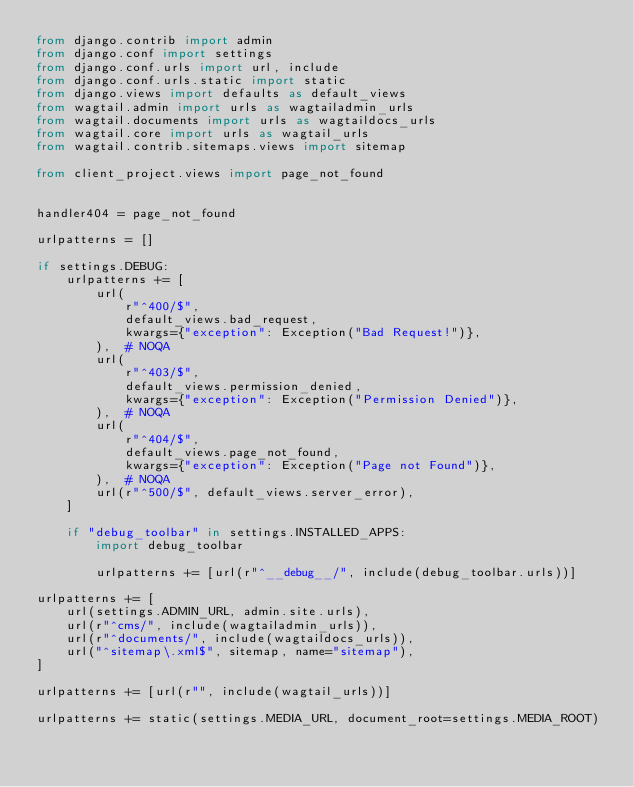<code> <loc_0><loc_0><loc_500><loc_500><_Python_>from django.contrib import admin
from django.conf import settings
from django.conf.urls import url, include
from django.conf.urls.static import static
from django.views import defaults as default_views
from wagtail.admin import urls as wagtailadmin_urls
from wagtail.documents import urls as wagtaildocs_urls
from wagtail.core import urls as wagtail_urls
from wagtail.contrib.sitemaps.views import sitemap

from client_project.views import page_not_found


handler404 = page_not_found

urlpatterns = []

if settings.DEBUG:
    urlpatterns += [
        url(
            r"^400/$",
            default_views.bad_request,
            kwargs={"exception": Exception("Bad Request!")},
        ),  # NOQA
        url(
            r"^403/$",
            default_views.permission_denied,
            kwargs={"exception": Exception("Permission Denied")},
        ),  # NOQA
        url(
            r"^404/$",
            default_views.page_not_found,
            kwargs={"exception": Exception("Page not Found")},
        ),  # NOQA
        url(r"^500/$", default_views.server_error),
    ]

    if "debug_toolbar" in settings.INSTALLED_APPS:
        import debug_toolbar

        urlpatterns += [url(r"^__debug__/", include(debug_toolbar.urls))]

urlpatterns += [
    url(settings.ADMIN_URL, admin.site.urls),
    url(r"^cms/", include(wagtailadmin_urls)),
    url(r"^documents/", include(wagtaildocs_urls)),
    url("^sitemap\.xml$", sitemap, name="sitemap"),
]

urlpatterns += [url(r"", include(wagtail_urls))]

urlpatterns += static(settings.MEDIA_URL, document_root=settings.MEDIA_ROOT)
</code> 